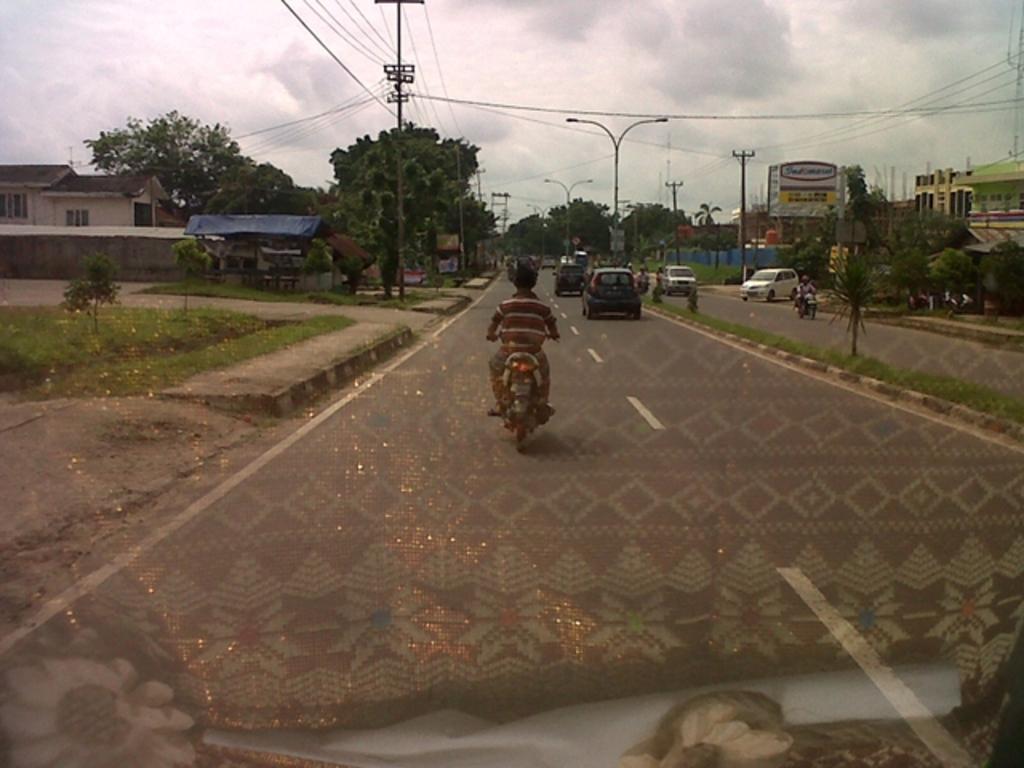Could you give a brief overview of what you see in this image? There are vehicles on the road. Here we can see grass, plants, trees, poles, houses, wires, and hoardings. In the background there is sky with clouds. 